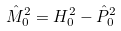<formula> <loc_0><loc_0><loc_500><loc_500>\hat { M } _ { 0 } ^ { 2 } = H _ { 0 } ^ { 2 } - \hat { P } _ { 0 } ^ { 2 }</formula> 